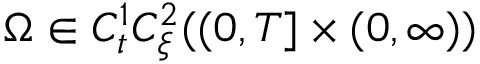<formula> <loc_0><loc_0><loc_500><loc_500>\Omega \in C _ { t } ^ { 1 } C _ { \xi } ^ { 2 } ( ( 0 , T ] \times ( 0 , \infty ) )</formula> 